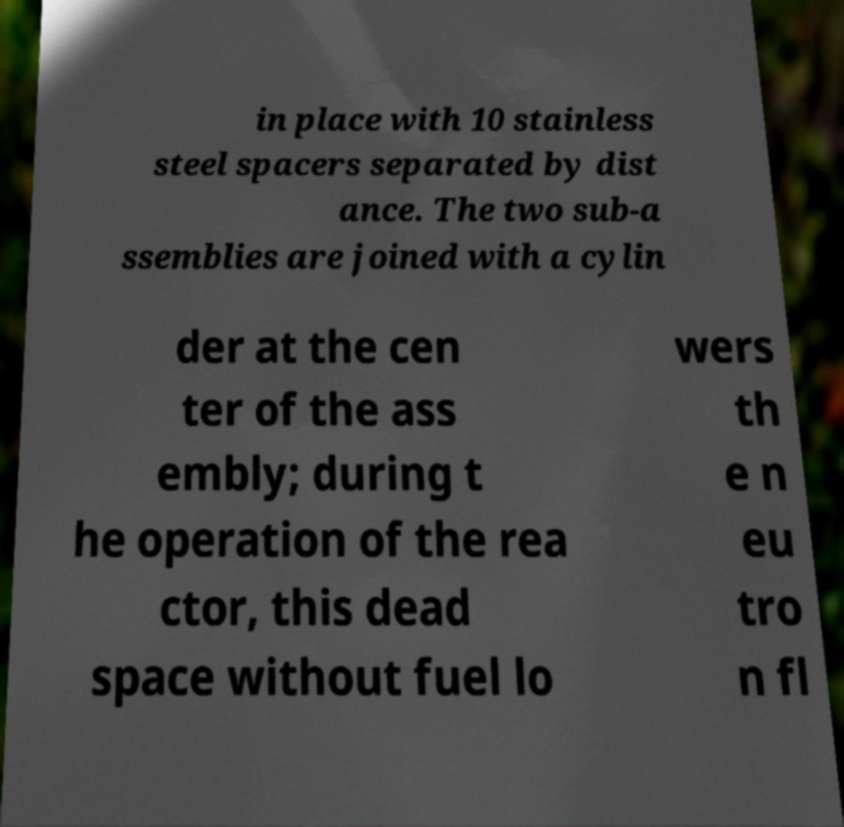What messages or text are displayed in this image? I need them in a readable, typed format. in place with 10 stainless steel spacers separated by dist ance. The two sub-a ssemblies are joined with a cylin der at the cen ter of the ass embly; during t he operation of the rea ctor, this dead space without fuel lo wers th e n eu tro n fl 